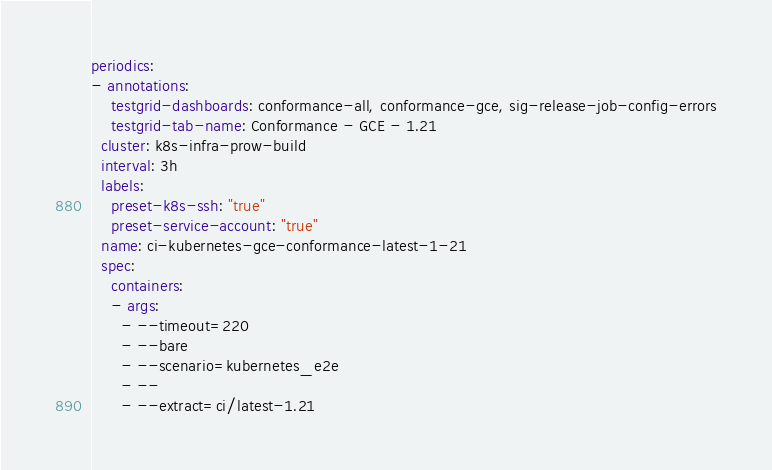Convert code to text. <code><loc_0><loc_0><loc_500><loc_500><_YAML_>periodics:
- annotations:
    testgrid-dashboards: conformance-all, conformance-gce, sig-release-job-config-errors
    testgrid-tab-name: Conformance - GCE - 1.21
  cluster: k8s-infra-prow-build
  interval: 3h
  labels:
    preset-k8s-ssh: "true"
    preset-service-account: "true"
  name: ci-kubernetes-gce-conformance-latest-1-21
  spec:
    containers:
    - args:
      - --timeout=220
      - --bare
      - --scenario=kubernetes_e2e
      - --
      - --extract=ci/latest-1.21</code> 